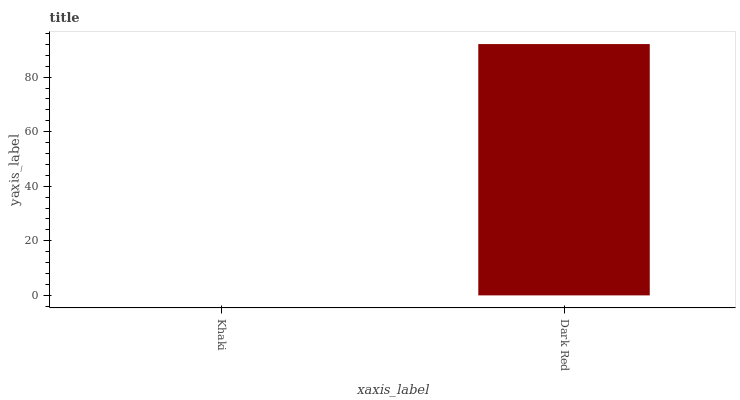Is Khaki the minimum?
Answer yes or no. Yes. Is Dark Red the maximum?
Answer yes or no. Yes. Is Dark Red the minimum?
Answer yes or no. No. Is Dark Red greater than Khaki?
Answer yes or no. Yes. Is Khaki less than Dark Red?
Answer yes or no. Yes. Is Khaki greater than Dark Red?
Answer yes or no. No. Is Dark Red less than Khaki?
Answer yes or no. No. Is Dark Red the high median?
Answer yes or no. Yes. Is Khaki the low median?
Answer yes or no. Yes. Is Khaki the high median?
Answer yes or no. No. Is Dark Red the low median?
Answer yes or no. No. 